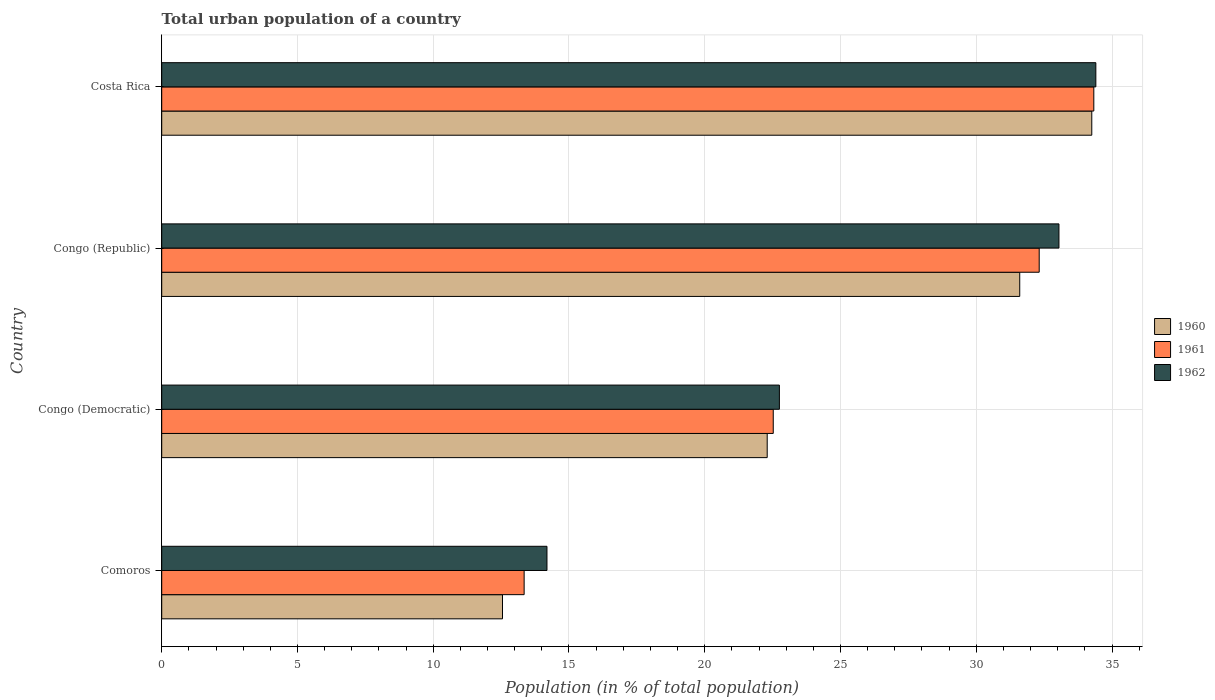How many groups of bars are there?
Your answer should be compact. 4. Are the number of bars per tick equal to the number of legend labels?
Provide a short and direct response. Yes. Are the number of bars on each tick of the Y-axis equal?
Give a very brief answer. Yes. What is the label of the 2nd group of bars from the top?
Offer a very short reply. Congo (Republic). In how many cases, is the number of bars for a given country not equal to the number of legend labels?
Keep it short and to the point. 0. What is the urban population in 1961 in Costa Rica?
Your response must be concise. 34.33. Across all countries, what is the maximum urban population in 1962?
Ensure brevity in your answer.  34.4. Across all countries, what is the minimum urban population in 1960?
Offer a very short reply. 12.55. In which country was the urban population in 1960 minimum?
Give a very brief answer. Comoros. What is the total urban population in 1960 in the graph?
Provide a succinct answer. 100.71. What is the difference between the urban population in 1962 in Comoros and that in Costa Rica?
Give a very brief answer. -20.22. What is the difference between the urban population in 1960 in Comoros and the urban population in 1962 in Costa Rica?
Make the answer very short. -21.85. What is the average urban population in 1961 per country?
Your response must be concise. 25.63. What is the difference between the urban population in 1962 and urban population in 1960 in Congo (Republic)?
Ensure brevity in your answer.  1.44. What is the ratio of the urban population in 1960 in Congo (Democratic) to that in Congo (Republic)?
Make the answer very short. 0.71. Is the urban population in 1960 in Comoros less than that in Congo (Democratic)?
Offer a very short reply. Yes. Is the difference between the urban population in 1962 in Congo (Democratic) and Congo (Republic) greater than the difference between the urban population in 1960 in Congo (Democratic) and Congo (Republic)?
Make the answer very short. No. What is the difference between the highest and the second highest urban population in 1962?
Provide a succinct answer. 1.36. What is the difference between the highest and the lowest urban population in 1962?
Ensure brevity in your answer.  20.22. What does the 1st bar from the top in Congo (Republic) represents?
Offer a very short reply. 1962. What does the 1st bar from the bottom in Costa Rica represents?
Offer a terse response. 1960. Are all the bars in the graph horizontal?
Provide a short and direct response. Yes. How many countries are there in the graph?
Give a very brief answer. 4. Are the values on the major ticks of X-axis written in scientific E-notation?
Your answer should be compact. No. Where does the legend appear in the graph?
Keep it short and to the point. Center right. What is the title of the graph?
Offer a very short reply. Total urban population of a country. Does "2001" appear as one of the legend labels in the graph?
Your answer should be very brief. No. What is the label or title of the X-axis?
Make the answer very short. Population (in % of total population). What is the label or title of the Y-axis?
Provide a succinct answer. Country. What is the Population (in % of total population) in 1960 in Comoros?
Give a very brief answer. 12.55. What is the Population (in % of total population) in 1961 in Comoros?
Give a very brief answer. 13.35. What is the Population (in % of total population) of 1962 in Comoros?
Keep it short and to the point. 14.19. What is the Population (in % of total population) of 1960 in Congo (Democratic)?
Keep it short and to the point. 22.3. What is the Population (in % of total population) of 1961 in Congo (Democratic)?
Provide a short and direct response. 22.52. What is the Population (in % of total population) in 1962 in Congo (Democratic)?
Offer a terse response. 22.75. What is the Population (in % of total population) in 1960 in Congo (Republic)?
Make the answer very short. 31.6. What is the Population (in % of total population) of 1961 in Congo (Republic)?
Give a very brief answer. 32.32. What is the Population (in % of total population) in 1962 in Congo (Republic)?
Provide a succinct answer. 33.05. What is the Population (in % of total population) of 1960 in Costa Rica?
Your answer should be compact. 34.25. What is the Population (in % of total population) in 1961 in Costa Rica?
Offer a very short reply. 34.33. What is the Population (in % of total population) in 1962 in Costa Rica?
Provide a short and direct response. 34.4. Across all countries, what is the maximum Population (in % of total population) of 1960?
Make the answer very short. 34.25. Across all countries, what is the maximum Population (in % of total population) in 1961?
Make the answer very short. 34.33. Across all countries, what is the maximum Population (in % of total population) in 1962?
Make the answer very short. 34.4. Across all countries, what is the minimum Population (in % of total population) of 1960?
Give a very brief answer. 12.55. Across all countries, what is the minimum Population (in % of total population) in 1961?
Your response must be concise. 13.35. Across all countries, what is the minimum Population (in % of total population) of 1962?
Your answer should be very brief. 14.19. What is the total Population (in % of total population) of 1960 in the graph?
Offer a terse response. 100.71. What is the total Population (in % of total population) of 1961 in the graph?
Your answer should be very brief. 102.52. What is the total Population (in % of total population) of 1962 in the graph?
Offer a terse response. 104.39. What is the difference between the Population (in % of total population) in 1960 in Comoros and that in Congo (Democratic)?
Provide a succinct answer. -9.75. What is the difference between the Population (in % of total population) of 1961 in Comoros and that in Congo (Democratic)?
Make the answer very short. -9.18. What is the difference between the Population (in % of total population) of 1962 in Comoros and that in Congo (Democratic)?
Your response must be concise. -8.56. What is the difference between the Population (in % of total population) of 1960 in Comoros and that in Congo (Republic)?
Offer a terse response. -19.05. What is the difference between the Population (in % of total population) of 1961 in Comoros and that in Congo (Republic)?
Your response must be concise. -18.97. What is the difference between the Population (in % of total population) of 1962 in Comoros and that in Congo (Republic)?
Make the answer very short. -18.86. What is the difference between the Population (in % of total population) in 1960 in Comoros and that in Costa Rica?
Ensure brevity in your answer.  -21.7. What is the difference between the Population (in % of total population) of 1961 in Comoros and that in Costa Rica?
Make the answer very short. -20.98. What is the difference between the Population (in % of total population) in 1962 in Comoros and that in Costa Rica?
Keep it short and to the point. -20.21. What is the difference between the Population (in % of total population) of 1960 in Congo (Democratic) and that in Congo (Republic)?
Give a very brief answer. -9.3. What is the difference between the Population (in % of total population) of 1961 in Congo (Democratic) and that in Congo (Republic)?
Keep it short and to the point. -9.79. What is the difference between the Population (in % of total population) of 1962 in Congo (Democratic) and that in Congo (Republic)?
Give a very brief answer. -10.3. What is the difference between the Population (in % of total population) of 1960 in Congo (Democratic) and that in Costa Rica?
Make the answer very short. -11.95. What is the difference between the Population (in % of total population) of 1961 in Congo (Democratic) and that in Costa Rica?
Ensure brevity in your answer.  -11.81. What is the difference between the Population (in % of total population) in 1962 in Congo (Democratic) and that in Costa Rica?
Make the answer very short. -11.65. What is the difference between the Population (in % of total population) of 1960 in Congo (Republic) and that in Costa Rica?
Provide a succinct answer. -2.65. What is the difference between the Population (in % of total population) of 1961 in Congo (Republic) and that in Costa Rica?
Make the answer very short. -2.01. What is the difference between the Population (in % of total population) of 1962 in Congo (Republic) and that in Costa Rica?
Provide a short and direct response. -1.36. What is the difference between the Population (in % of total population) in 1960 in Comoros and the Population (in % of total population) in 1961 in Congo (Democratic)?
Provide a succinct answer. -9.97. What is the difference between the Population (in % of total population) in 1960 in Comoros and the Population (in % of total population) in 1962 in Congo (Democratic)?
Your answer should be very brief. -10.2. What is the difference between the Population (in % of total population) of 1961 in Comoros and the Population (in % of total population) of 1962 in Congo (Democratic)?
Your response must be concise. -9.4. What is the difference between the Population (in % of total population) of 1960 in Comoros and the Population (in % of total population) of 1961 in Congo (Republic)?
Offer a very short reply. -19.77. What is the difference between the Population (in % of total population) in 1960 in Comoros and the Population (in % of total population) in 1962 in Congo (Republic)?
Keep it short and to the point. -20.49. What is the difference between the Population (in % of total population) in 1961 in Comoros and the Population (in % of total population) in 1962 in Congo (Republic)?
Offer a very short reply. -19.7. What is the difference between the Population (in % of total population) of 1960 in Comoros and the Population (in % of total population) of 1961 in Costa Rica?
Give a very brief answer. -21.78. What is the difference between the Population (in % of total population) of 1960 in Comoros and the Population (in % of total population) of 1962 in Costa Rica?
Provide a succinct answer. -21.85. What is the difference between the Population (in % of total population) of 1961 in Comoros and the Population (in % of total population) of 1962 in Costa Rica?
Keep it short and to the point. -21.06. What is the difference between the Population (in % of total population) in 1960 in Congo (Democratic) and the Population (in % of total population) in 1961 in Congo (Republic)?
Ensure brevity in your answer.  -10.02. What is the difference between the Population (in % of total population) in 1960 in Congo (Democratic) and the Population (in % of total population) in 1962 in Congo (Republic)?
Provide a succinct answer. -10.74. What is the difference between the Population (in % of total population) of 1961 in Congo (Democratic) and the Population (in % of total population) of 1962 in Congo (Republic)?
Provide a succinct answer. -10.52. What is the difference between the Population (in % of total population) in 1960 in Congo (Democratic) and the Population (in % of total population) in 1961 in Costa Rica?
Keep it short and to the point. -12.03. What is the difference between the Population (in % of total population) in 1960 in Congo (Democratic) and the Population (in % of total population) in 1962 in Costa Rica?
Ensure brevity in your answer.  -12.1. What is the difference between the Population (in % of total population) of 1961 in Congo (Democratic) and the Population (in % of total population) of 1962 in Costa Rica?
Offer a terse response. -11.88. What is the difference between the Population (in % of total population) in 1960 in Congo (Republic) and the Population (in % of total population) in 1961 in Costa Rica?
Ensure brevity in your answer.  -2.73. What is the difference between the Population (in % of total population) of 1960 in Congo (Republic) and the Population (in % of total population) of 1962 in Costa Rica?
Your answer should be compact. -2.8. What is the difference between the Population (in % of total population) in 1961 in Congo (Republic) and the Population (in % of total population) in 1962 in Costa Rica?
Keep it short and to the point. -2.09. What is the average Population (in % of total population) in 1960 per country?
Offer a very short reply. 25.18. What is the average Population (in % of total population) of 1961 per country?
Make the answer very short. 25.63. What is the average Population (in % of total population) of 1962 per country?
Make the answer very short. 26.1. What is the difference between the Population (in % of total population) in 1960 and Population (in % of total population) in 1961 in Comoros?
Keep it short and to the point. -0.8. What is the difference between the Population (in % of total population) of 1960 and Population (in % of total population) of 1962 in Comoros?
Provide a succinct answer. -1.64. What is the difference between the Population (in % of total population) of 1961 and Population (in % of total population) of 1962 in Comoros?
Provide a succinct answer. -0.84. What is the difference between the Population (in % of total population) in 1960 and Population (in % of total population) in 1961 in Congo (Democratic)?
Your response must be concise. -0.22. What is the difference between the Population (in % of total population) in 1960 and Population (in % of total population) in 1962 in Congo (Democratic)?
Offer a very short reply. -0.45. What is the difference between the Population (in % of total population) in 1961 and Population (in % of total population) in 1962 in Congo (Democratic)?
Your response must be concise. -0.23. What is the difference between the Population (in % of total population) of 1960 and Population (in % of total population) of 1961 in Congo (Republic)?
Your answer should be compact. -0.72. What is the difference between the Population (in % of total population) of 1960 and Population (in % of total population) of 1962 in Congo (Republic)?
Ensure brevity in your answer.  -1.44. What is the difference between the Population (in % of total population) in 1961 and Population (in % of total population) in 1962 in Congo (Republic)?
Make the answer very short. -0.73. What is the difference between the Population (in % of total population) in 1960 and Population (in % of total population) in 1961 in Costa Rica?
Provide a succinct answer. -0.07. What is the difference between the Population (in % of total population) in 1961 and Population (in % of total population) in 1962 in Costa Rica?
Make the answer very short. -0.07. What is the ratio of the Population (in % of total population) of 1960 in Comoros to that in Congo (Democratic)?
Keep it short and to the point. 0.56. What is the ratio of the Population (in % of total population) of 1961 in Comoros to that in Congo (Democratic)?
Provide a short and direct response. 0.59. What is the ratio of the Population (in % of total population) of 1962 in Comoros to that in Congo (Democratic)?
Your answer should be compact. 0.62. What is the ratio of the Population (in % of total population) in 1960 in Comoros to that in Congo (Republic)?
Offer a terse response. 0.4. What is the ratio of the Population (in % of total population) of 1961 in Comoros to that in Congo (Republic)?
Give a very brief answer. 0.41. What is the ratio of the Population (in % of total population) in 1962 in Comoros to that in Congo (Republic)?
Give a very brief answer. 0.43. What is the ratio of the Population (in % of total population) in 1960 in Comoros to that in Costa Rica?
Offer a very short reply. 0.37. What is the ratio of the Population (in % of total population) of 1961 in Comoros to that in Costa Rica?
Ensure brevity in your answer.  0.39. What is the ratio of the Population (in % of total population) of 1962 in Comoros to that in Costa Rica?
Offer a very short reply. 0.41. What is the ratio of the Population (in % of total population) of 1960 in Congo (Democratic) to that in Congo (Republic)?
Give a very brief answer. 0.71. What is the ratio of the Population (in % of total population) in 1961 in Congo (Democratic) to that in Congo (Republic)?
Your answer should be very brief. 0.7. What is the ratio of the Population (in % of total population) of 1962 in Congo (Democratic) to that in Congo (Republic)?
Your answer should be very brief. 0.69. What is the ratio of the Population (in % of total population) of 1960 in Congo (Democratic) to that in Costa Rica?
Your response must be concise. 0.65. What is the ratio of the Population (in % of total population) in 1961 in Congo (Democratic) to that in Costa Rica?
Your answer should be compact. 0.66. What is the ratio of the Population (in % of total population) in 1962 in Congo (Democratic) to that in Costa Rica?
Provide a succinct answer. 0.66. What is the ratio of the Population (in % of total population) of 1960 in Congo (Republic) to that in Costa Rica?
Your answer should be very brief. 0.92. What is the ratio of the Population (in % of total population) in 1961 in Congo (Republic) to that in Costa Rica?
Provide a short and direct response. 0.94. What is the ratio of the Population (in % of total population) of 1962 in Congo (Republic) to that in Costa Rica?
Keep it short and to the point. 0.96. What is the difference between the highest and the second highest Population (in % of total population) in 1960?
Your answer should be very brief. 2.65. What is the difference between the highest and the second highest Population (in % of total population) of 1961?
Give a very brief answer. 2.01. What is the difference between the highest and the second highest Population (in % of total population) of 1962?
Make the answer very short. 1.36. What is the difference between the highest and the lowest Population (in % of total population) of 1960?
Offer a terse response. 21.7. What is the difference between the highest and the lowest Population (in % of total population) in 1961?
Offer a very short reply. 20.98. What is the difference between the highest and the lowest Population (in % of total population) of 1962?
Make the answer very short. 20.21. 